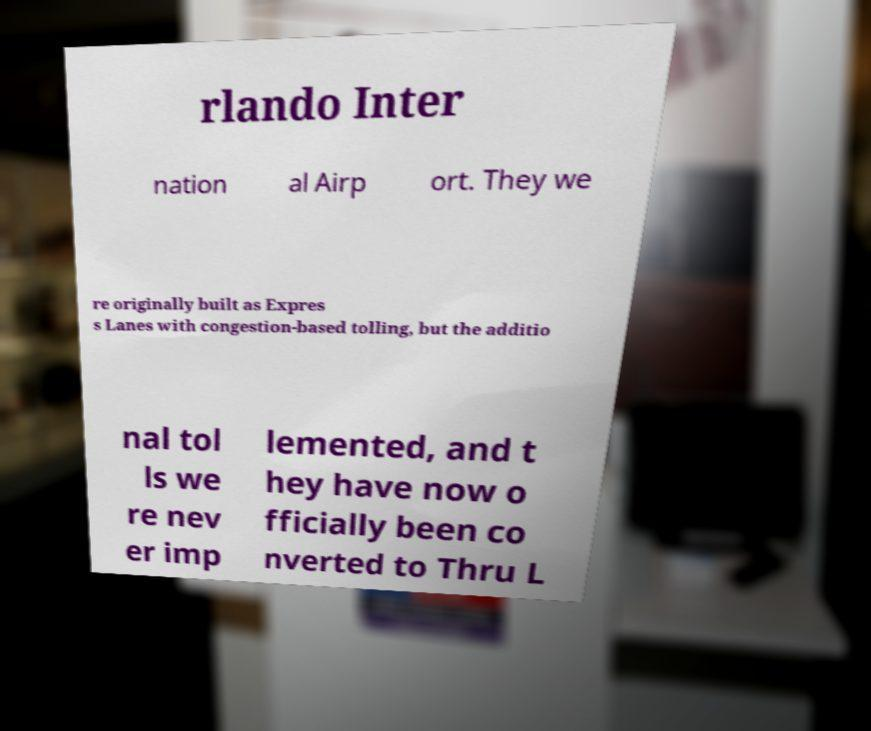Could you assist in decoding the text presented in this image and type it out clearly? rlando Inter nation al Airp ort. They we re originally built as Expres s Lanes with congestion-based tolling, but the additio nal tol ls we re nev er imp lemented, and t hey have now o fficially been co nverted to Thru L 